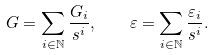<formula> <loc_0><loc_0><loc_500><loc_500>G = \sum _ { i \in \mathbb { N } } \frac { G _ { i } } { s ^ { i } } , \quad \varepsilon = \sum _ { i \in \mathbb { N } } \frac { \varepsilon _ { i } } { s ^ { i } } .</formula> 